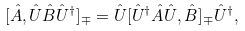Convert formula to latex. <formula><loc_0><loc_0><loc_500><loc_500>[ \hat { A } , \hat { U } \hat { B } \hat { U } ^ { \dagger } ] _ { \mp } = \hat { U } [ \hat { U } ^ { \dagger } \hat { A } \hat { U } , \hat { B } ] _ { \mp } \hat { U } ^ { \dagger } ,</formula> 